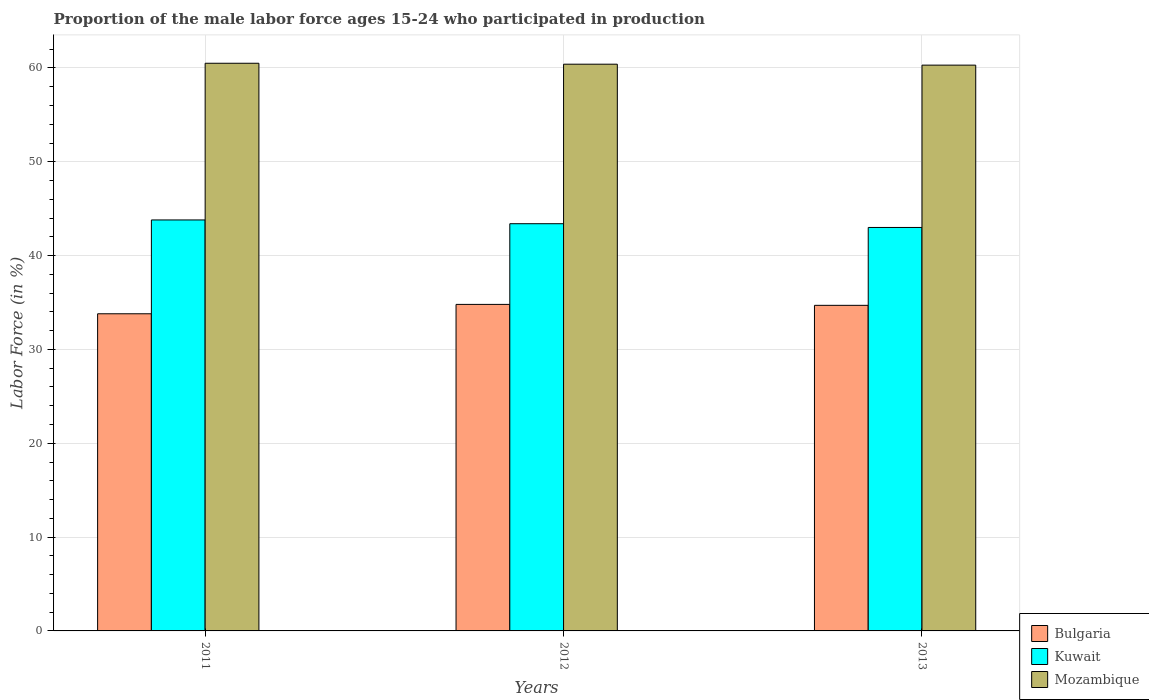How many different coloured bars are there?
Your answer should be very brief. 3. How many groups of bars are there?
Provide a short and direct response. 3. Are the number of bars per tick equal to the number of legend labels?
Ensure brevity in your answer.  Yes. What is the proportion of the male labor force who participated in production in Bulgaria in 2013?
Offer a very short reply. 34.7. Across all years, what is the maximum proportion of the male labor force who participated in production in Bulgaria?
Ensure brevity in your answer.  34.8. Across all years, what is the minimum proportion of the male labor force who participated in production in Mozambique?
Ensure brevity in your answer.  60.3. In which year was the proportion of the male labor force who participated in production in Mozambique minimum?
Your answer should be very brief. 2013. What is the total proportion of the male labor force who participated in production in Bulgaria in the graph?
Offer a terse response. 103.3. What is the difference between the proportion of the male labor force who participated in production in Bulgaria in 2011 and that in 2013?
Offer a terse response. -0.9. What is the difference between the proportion of the male labor force who participated in production in Kuwait in 2011 and the proportion of the male labor force who participated in production in Bulgaria in 2013?
Your answer should be very brief. 9.1. What is the average proportion of the male labor force who participated in production in Bulgaria per year?
Ensure brevity in your answer.  34.43. In the year 2011, what is the difference between the proportion of the male labor force who participated in production in Kuwait and proportion of the male labor force who participated in production in Mozambique?
Provide a succinct answer. -16.7. In how many years, is the proportion of the male labor force who participated in production in Bulgaria greater than 4 %?
Offer a very short reply. 3. What is the ratio of the proportion of the male labor force who participated in production in Kuwait in 2011 to that in 2012?
Make the answer very short. 1.01. Is the proportion of the male labor force who participated in production in Bulgaria in 2012 less than that in 2013?
Offer a very short reply. No. Is the difference between the proportion of the male labor force who participated in production in Kuwait in 2011 and 2013 greater than the difference between the proportion of the male labor force who participated in production in Mozambique in 2011 and 2013?
Offer a terse response. Yes. What is the difference between the highest and the second highest proportion of the male labor force who participated in production in Mozambique?
Ensure brevity in your answer.  0.1. What is the difference between the highest and the lowest proportion of the male labor force who participated in production in Mozambique?
Ensure brevity in your answer.  0.2. In how many years, is the proportion of the male labor force who participated in production in Bulgaria greater than the average proportion of the male labor force who participated in production in Bulgaria taken over all years?
Provide a short and direct response. 2. Is the sum of the proportion of the male labor force who participated in production in Mozambique in 2011 and 2013 greater than the maximum proportion of the male labor force who participated in production in Bulgaria across all years?
Your answer should be very brief. Yes. What does the 3rd bar from the left in 2013 represents?
Provide a succinct answer. Mozambique. How many bars are there?
Provide a short and direct response. 9. Are all the bars in the graph horizontal?
Your response must be concise. No. How many years are there in the graph?
Your response must be concise. 3. Are the values on the major ticks of Y-axis written in scientific E-notation?
Ensure brevity in your answer.  No. Does the graph contain any zero values?
Offer a terse response. No. Does the graph contain grids?
Offer a very short reply. Yes. Where does the legend appear in the graph?
Ensure brevity in your answer.  Bottom right. How many legend labels are there?
Offer a terse response. 3. How are the legend labels stacked?
Your answer should be very brief. Vertical. What is the title of the graph?
Ensure brevity in your answer.  Proportion of the male labor force ages 15-24 who participated in production. Does "Luxembourg" appear as one of the legend labels in the graph?
Ensure brevity in your answer.  No. What is the label or title of the Y-axis?
Offer a very short reply. Labor Force (in %). What is the Labor Force (in %) in Bulgaria in 2011?
Make the answer very short. 33.8. What is the Labor Force (in %) in Kuwait in 2011?
Ensure brevity in your answer.  43.8. What is the Labor Force (in %) in Mozambique in 2011?
Offer a terse response. 60.5. What is the Labor Force (in %) of Bulgaria in 2012?
Give a very brief answer. 34.8. What is the Labor Force (in %) of Kuwait in 2012?
Offer a terse response. 43.4. What is the Labor Force (in %) in Mozambique in 2012?
Make the answer very short. 60.4. What is the Labor Force (in %) of Bulgaria in 2013?
Your answer should be very brief. 34.7. What is the Labor Force (in %) of Mozambique in 2013?
Your answer should be very brief. 60.3. Across all years, what is the maximum Labor Force (in %) in Bulgaria?
Provide a succinct answer. 34.8. Across all years, what is the maximum Labor Force (in %) of Kuwait?
Make the answer very short. 43.8. Across all years, what is the maximum Labor Force (in %) in Mozambique?
Offer a very short reply. 60.5. Across all years, what is the minimum Labor Force (in %) in Bulgaria?
Your answer should be compact. 33.8. Across all years, what is the minimum Labor Force (in %) of Kuwait?
Make the answer very short. 43. Across all years, what is the minimum Labor Force (in %) in Mozambique?
Your answer should be very brief. 60.3. What is the total Labor Force (in %) of Bulgaria in the graph?
Give a very brief answer. 103.3. What is the total Labor Force (in %) in Kuwait in the graph?
Offer a terse response. 130.2. What is the total Labor Force (in %) of Mozambique in the graph?
Provide a succinct answer. 181.2. What is the difference between the Labor Force (in %) in Mozambique in 2011 and that in 2012?
Keep it short and to the point. 0.1. What is the difference between the Labor Force (in %) in Bulgaria in 2011 and that in 2013?
Ensure brevity in your answer.  -0.9. What is the difference between the Labor Force (in %) in Mozambique in 2011 and that in 2013?
Provide a short and direct response. 0.2. What is the difference between the Labor Force (in %) in Mozambique in 2012 and that in 2013?
Your answer should be compact. 0.1. What is the difference between the Labor Force (in %) in Bulgaria in 2011 and the Labor Force (in %) in Kuwait in 2012?
Offer a very short reply. -9.6. What is the difference between the Labor Force (in %) of Bulgaria in 2011 and the Labor Force (in %) of Mozambique in 2012?
Make the answer very short. -26.6. What is the difference between the Labor Force (in %) in Kuwait in 2011 and the Labor Force (in %) in Mozambique in 2012?
Your answer should be very brief. -16.6. What is the difference between the Labor Force (in %) of Bulgaria in 2011 and the Labor Force (in %) of Mozambique in 2013?
Your answer should be compact. -26.5. What is the difference between the Labor Force (in %) in Kuwait in 2011 and the Labor Force (in %) in Mozambique in 2013?
Keep it short and to the point. -16.5. What is the difference between the Labor Force (in %) in Bulgaria in 2012 and the Labor Force (in %) in Mozambique in 2013?
Your response must be concise. -25.5. What is the difference between the Labor Force (in %) in Kuwait in 2012 and the Labor Force (in %) in Mozambique in 2013?
Make the answer very short. -16.9. What is the average Labor Force (in %) of Bulgaria per year?
Offer a terse response. 34.43. What is the average Labor Force (in %) of Kuwait per year?
Make the answer very short. 43.4. What is the average Labor Force (in %) of Mozambique per year?
Offer a terse response. 60.4. In the year 2011, what is the difference between the Labor Force (in %) in Bulgaria and Labor Force (in %) in Kuwait?
Provide a succinct answer. -10. In the year 2011, what is the difference between the Labor Force (in %) in Bulgaria and Labor Force (in %) in Mozambique?
Keep it short and to the point. -26.7. In the year 2011, what is the difference between the Labor Force (in %) in Kuwait and Labor Force (in %) in Mozambique?
Your response must be concise. -16.7. In the year 2012, what is the difference between the Labor Force (in %) of Bulgaria and Labor Force (in %) of Mozambique?
Provide a short and direct response. -25.6. In the year 2012, what is the difference between the Labor Force (in %) of Kuwait and Labor Force (in %) of Mozambique?
Your answer should be compact. -17. In the year 2013, what is the difference between the Labor Force (in %) of Bulgaria and Labor Force (in %) of Mozambique?
Provide a short and direct response. -25.6. In the year 2013, what is the difference between the Labor Force (in %) of Kuwait and Labor Force (in %) of Mozambique?
Offer a very short reply. -17.3. What is the ratio of the Labor Force (in %) in Bulgaria in 2011 to that in 2012?
Your answer should be very brief. 0.97. What is the ratio of the Labor Force (in %) of Kuwait in 2011 to that in 2012?
Your answer should be compact. 1.01. What is the ratio of the Labor Force (in %) of Bulgaria in 2011 to that in 2013?
Offer a very short reply. 0.97. What is the ratio of the Labor Force (in %) of Kuwait in 2011 to that in 2013?
Make the answer very short. 1.02. What is the ratio of the Labor Force (in %) in Mozambique in 2011 to that in 2013?
Your response must be concise. 1. What is the ratio of the Labor Force (in %) of Kuwait in 2012 to that in 2013?
Your answer should be compact. 1.01. What is the difference between the highest and the second highest Labor Force (in %) in Kuwait?
Your response must be concise. 0.4. What is the difference between the highest and the lowest Labor Force (in %) of Bulgaria?
Keep it short and to the point. 1. 